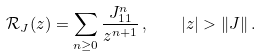<formula> <loc_0><loc_0><loc_500><loc_500>\mathcal { R } _ { J } ( z ) = \sum _ { n \geq 0 } \frac { J ^ { n } _ { 1 1 } } { z ^ { n + 1 } } \, , \quad | z | > \| J \| \, .</formula> 